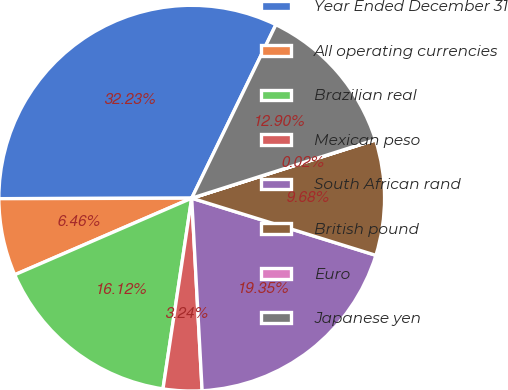Convert chart. <chart><loc_0><loc_0><loc_500><loc_500><pie_chart><fcel>Year Ended December 31<fcel>All operating currencies<fcel>Brazilian real<fcel>Mexican peso<fcel>South African rand<fcel>British pound<fcel>Euro<fcel>Japanese yen<nl><fcel>32.23%<fcel>6.46%<fcel>16.12%<fcel>3.24%<fcel>19.35%<fcel>9.68%<fcel>0.02%<fcel>12.9%<nl></chart> 